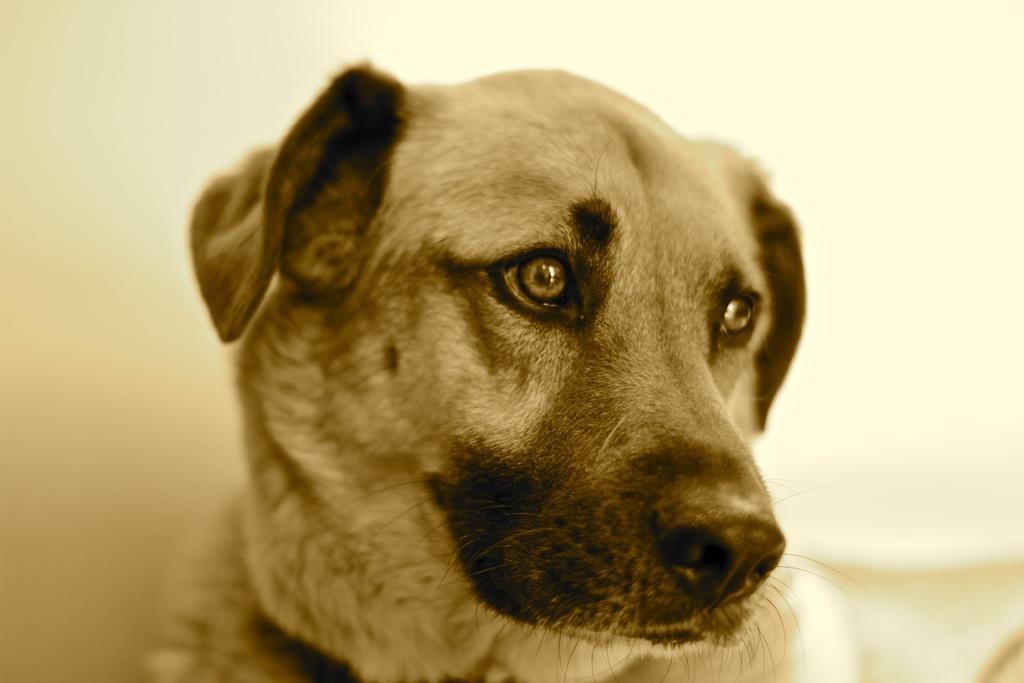Could you give a brief overview of what you see in this image? In this image we can see a dog. In the background we can see wall and an object on the right side. 